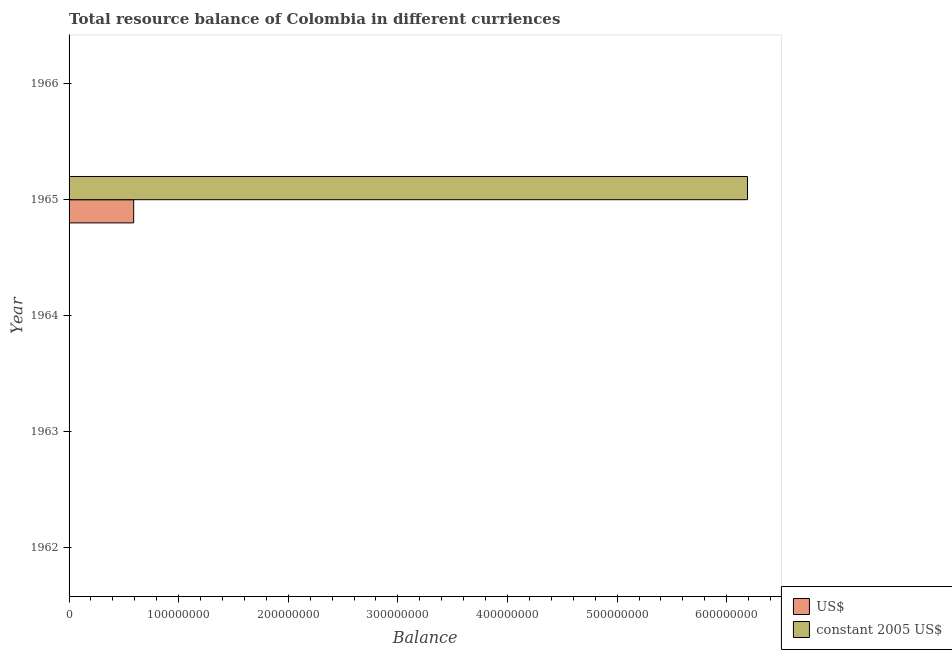How many different coloured bars are there?
Make the answer very short. 2. How many bars are there on the 2nd tick from the bottom?
Offer a terse response. 0. What is the label of the 1st group of bars from the top?
Your answer should be compact. 1966. In how many cases, is the number of bars for a given year not equal to the number of legend labels?
Offer a terse response. 4. What is the resource balance in constant us$ in 1964?
Your answer should be very brief. 0. Across all years, what is the maximum resource balance in constant us$?
Provide a succinct answer. 6.19e+08. In which year was the resource balance in constant us$ maximum?
Your response must be concise. 1965. What is the total resource balance in us$ in the graph?
Make the answer very short. 5.90e+07. What is the difference between the resource balance in us$ in 1965 and the resource balance in constant us$ in 1966?
Your answer should be compact. 5.90e+07. What is the average resource balance in constant us$ per year?
Offer a terse response. 1.24e+08. In the year 1965, what is the difference between the resource balance in us$ and resource balance in constant us$?
Offer a terse response. -5.60e+08. What is the difference between the highest and the lowest resource balance in constant us$?
Provide a short and direct response. 6.19e+08. In how many years, is the resource balance in constant us$ greater than the average resource balance in constant us$ taken over all years?
Offer a terse response. 1. How many bars are there?
Your answer should be very brief. 2. How many years are there in the graph?
Your answer should be compact. 5. Are the values on the major ticks of X-axis written in scientific E-notation?
Your answer should be compact. No. How many legend labels are there?
Your response must be concise. 2. What is the title of the graph?
Provide a succinct answer. Total resource balance of Colombia in different curriences. What is the label or title of the X-axis?
Offer a terse response. Balance. What is the Balance of constant 2005 US$ in 1962?
Provide a succinct answer. 0. What is the Balance of US$ in 1963?
Offer a terse response. 0. What is the Balance of constant 2005 US$ in 1964?
Offer a terse response. 0. What is the Balance of US$ in 1965?
Give a very brief answer. 5.90e+07. What is the Balance of constant 2005 US$ in 1965?
Your answer should be compact. 6.19e+08. What is the Balance in US$ in 1966?
Make the answer very short. 0. What is the Balance of constant 2005 US$ in 1966?
Offer a terse response. 0. Across all years, what is the maximum Balance in US$?
Your answer should be very brief. 5.90e+07. Across all years, what is the maximum Balance in constant 2005 US$?
Your response must be concise. 6.19e+08. Across all years, what is the minimum Balance of US$?
Make the answer very short. 0. Across all years, what is the minimum Balance in constant 2005 US$?
Your answer should be very brief. 0. What is the total Balance of US$ in the graph?
Your answer should be compact. 5.90e+07. What is the total Balance of constant 2005 US$ in the graph?
Offer a terse response. 6.19e+08. What is the average Balance in US$ per year?
Offer a very short reply. 1.18e+07. What is the average Balance of constant 2005 US$ per year?
Keep it short and to the point. 1.24e+08. In the year 1965, what is the difference between the Balance in US$ and Balance in constant 2005 US$?
Keep it short and to the point. -5.60e+08. What is the difference between the highest and the lowest Balance of US$?
Offer a terse response. 5.90e+07. What is the difference between the highest and the lowest Balance of constant 2005 US$?
Your answer should be very brief. 6.19e+08. 